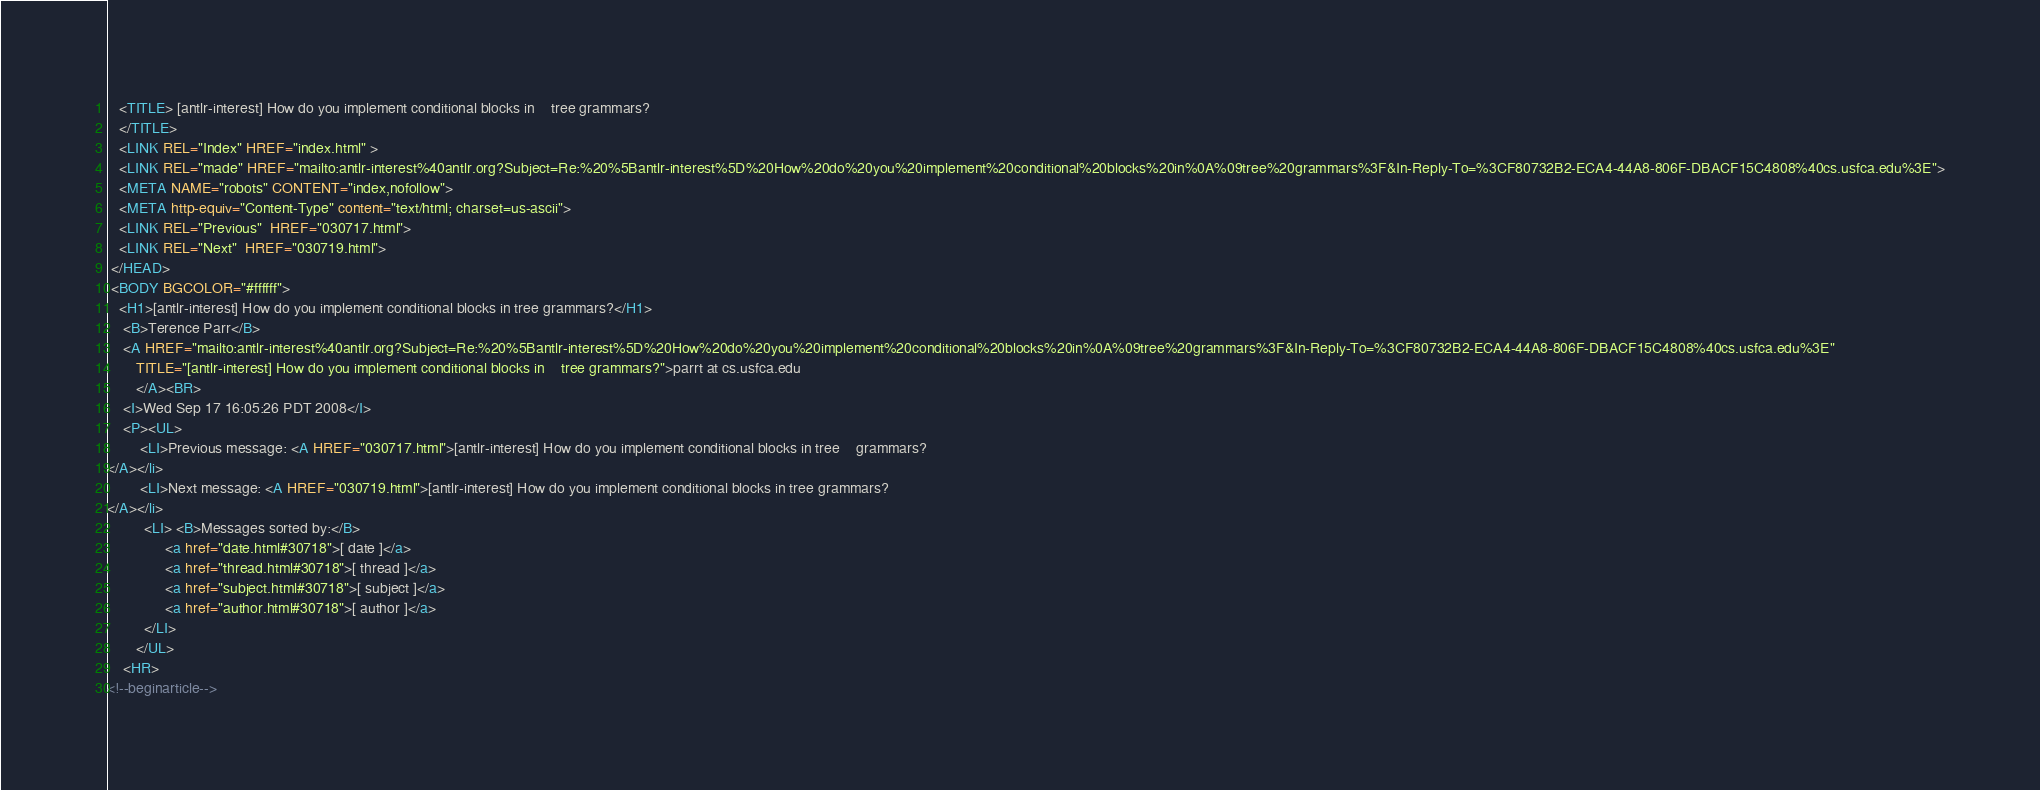<code> <loc_0><loc_0><loc_500><loc_500><_HTML_>   <TITLE> [antlr-interest] How do you implement conditional blocks in	tree grammars?
   </TITLE>
   <LINK REL="Index" HREF="index.html" >
   <LINK REL="made" HREF="mailto:antlr-interest%40antlr.org?Subject=Re:%20%5Bantlr-interest%5D%20How%20do%20you%20implement%20conditional%20blocks%20in%0A%09tree%20grammars%3F&In-Reply-To=%3CF80732B2-ECA4-44A8-806F-DBACF15C4808%40cs.usfca.edu%3E">
   <META NAME="robots" CONTENT="index,nofollow">
   <META http-equiv="Content-Type" content="text/html; charset=us-ascii">
   <LINK REL="Previous"  HREF="030717.html">
   <LINK REL="Next"  HREF="030719.html">
 </HEAD>
 <BODY BGCOLOR="#ffffff">
   <H1>[antlr-interest] How do you implement conditional blocks in	tree grammars?</H1>
    <B>Terence Parr</B> 
    <A HREF="mailto:antlr-interest%40antlr.org?Subject=Re:%20%5Bantlr-interest%5D%20How%20do%20you%20implement%20conditional%20blocks%20in%0A%09tree%20grammars%3F&In-Reply-To=%3CF80732B2-ECA4-44A8-806F-DBACF15C4808%40cs.usfca.edu%3E"
       TITLE="[antlr-interest] How do you implement conditional blocks in	tree grammars?">parrt at cs.usfca.edu
       </A><BR>
    <I>Wed Sep 17 16:05:26 PDT 2008</I>
    <P><UL>
        <LI>Previous message: <A HREF="030717.html">[antlr-interest] How do you implement conditional blocks in tree	grammars?
</A></li>
        <LI>Next message: <A HREF="030719.html">[antlr-interest] How do you implement conditional blocks in	tree grammars?
</A></li>
         <LI> <B>Messages sorted by:</B> 
              <a href="date.html#30718">[ date ]</a>
              <a href="thread.html#30718">[ thread ]</a>
              <a href="subject.html#30718">[ subject ]</a>
              <a href="author.html#30718">[ author ]</a>
         </LI>
       </UL>
    <HR>  
<!--beginarticle--></code> 